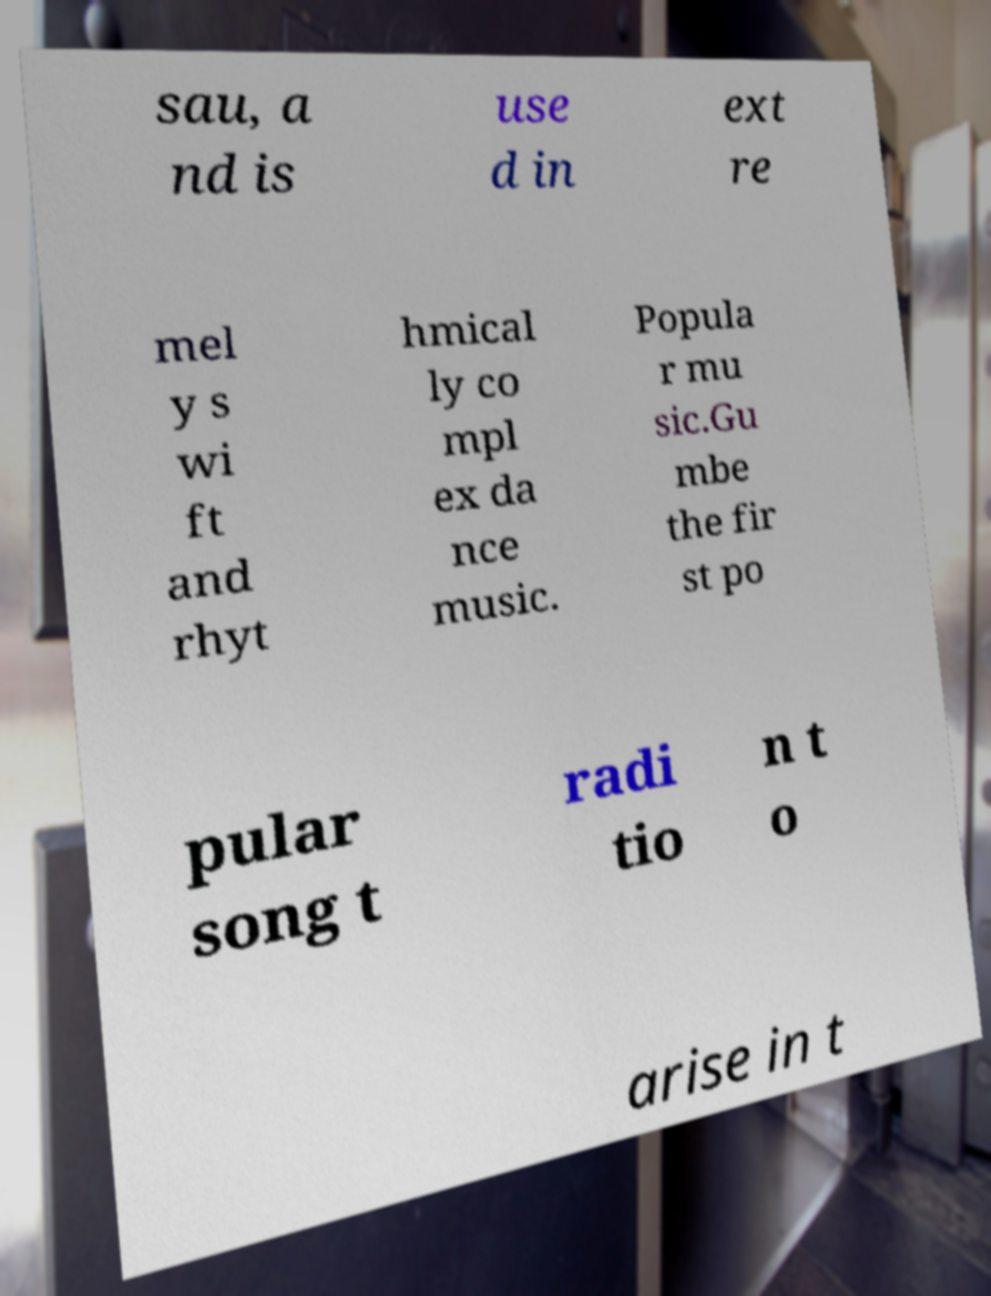What messages or text are displayed in this image? I need them in a readable, typed format. sau, a nd is use d in ext re mel y s wi ft and rhyt hmical ly co mpl ex da nce music. Popula r mu sic.Gu mbe the fir st po pular song t radi tio n t o arise in t 